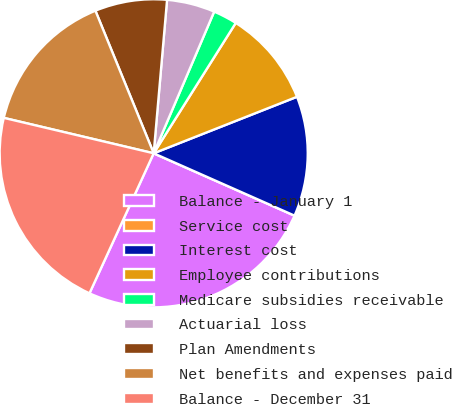Convert chart to OTSL. <chart><loc_0><loc_0><loc_500><loc_500><pie_chart><fcel>Balance - January 1<fcel>Service cost<fcel>Interest cost<fcel>Employee contributions<fcel>Medicare subsidies receivable<fcel>Actuarial loss<fcel>Plan Amendments<fcel>Net benefits and expenses paid<fcel>Balance - December 31<nl><fcel>25.21%<fcel>0.0%<fcel>12.61%<fcel>10.08%<fcel>2.52%<fcel>5.04%<fcel>7.56%<fcel>15.13%<fcel>21.85%<nl></chart> 